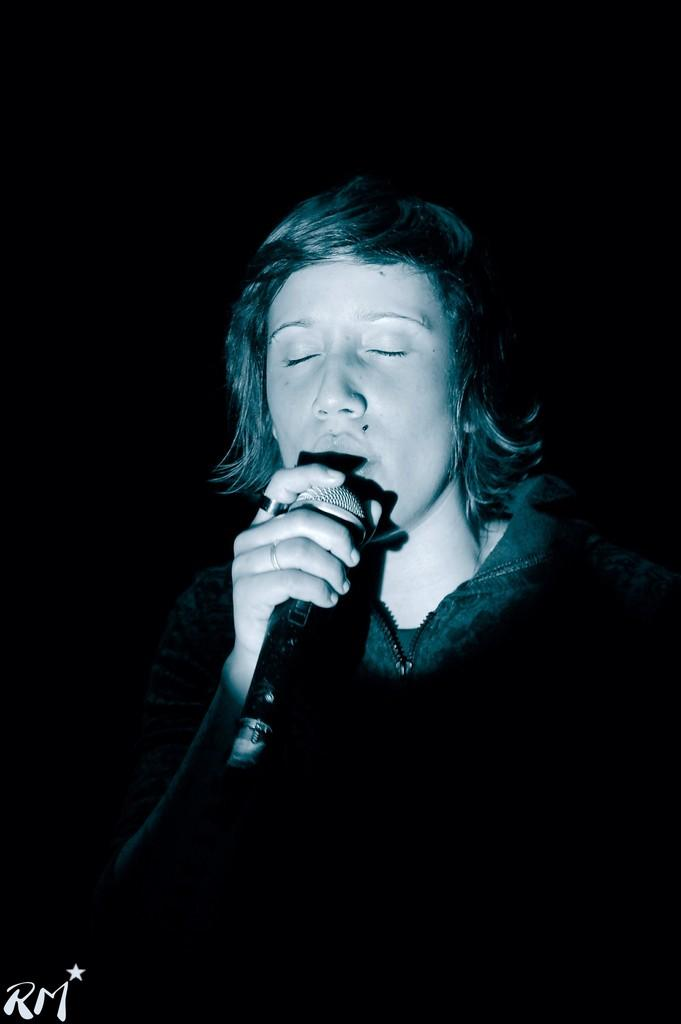What is the main subject of the image? There is a person in the image. What is the person holding in the image? The person is holding a mic. Can you describe the background of the image? The background of the image is dark. Is there any text visible in the image? Yes, there is some text at the bottom right side of the image. Can you see any grass in the image? There is no grass visible in the image. Is the person in the image in a prison? There is no indication in the image that the person is in a prison. What type of amusement can be seen in the image? There is no amusement depicted in the image; it features a person holding a mic against a dark background with some text. 